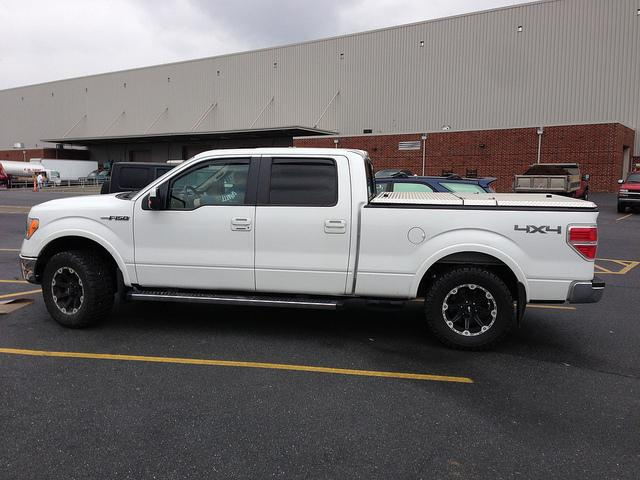What is the answer to the equation on the side of the truck? Please explain your reasoning. 16. The equation is four multiplied by itself. 